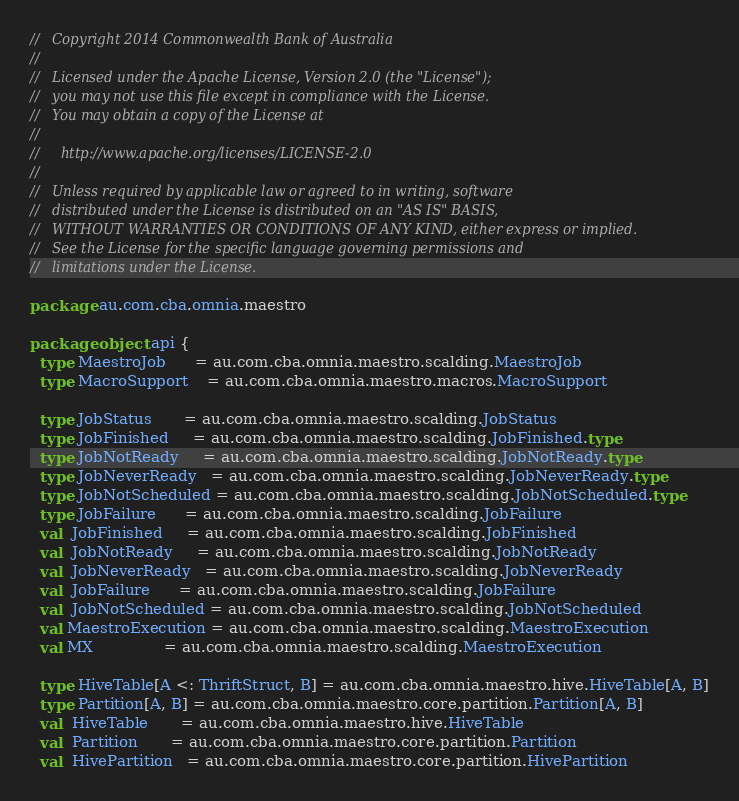<code> <loc_0><loc_0><loc_500><loc_500><_Scala_>//   Copyright 2014 Commonwealth Bank of Australia
//
//   Licensed under the Apache License, Version 2.0 (the "License");
//   you may not use this file except in compliance with the License.
//   You may obtain a copy of the License at
//
//     http://www.apache.org/licenses/LICENSE-2.0
//
//   Unless required by applicable law or agreed to in writing, software
//   distributed under the License is distributed on an "AS IS" BASIS,
//   WITHOUT WARRANTIES OR CONDITIONS OF ANY KIND, either express or implied.
//   See the License for the specific language governing permissions and
//   limitations under the License.

package au.com.cba.omnia.maestro

package object api {
  type MaestroJob      = au.com.cba.omnia.maestro.scalding.MaestroJob
  type MacroSupport    = au.com.cba.omnia.maestro.macros.MacroSupport

  type JobStatus       = au.com.cba.omnia.maestro.scalding.JobStatus
  type JobFinished     = au.com.cba.omnia.maestro.scalding.JobFinished.type
  type JobNotReady     = au.com.cba.omnia.maestro.scalding.JobNotReady.type
  type JobNeverReady   = au.com.cba.omnia.maestro.scalding.JobNeverReady.type
  type JobNotScheduled = au.com.cba.omnia.maestro.scalding.JobNotScheduled.type
  type JobFailure      = au.com.cba.omnia.maestro.scalding.JobFailure
  val  JobFinished     = au.com.cba.omnia.maestro.scalding.JobFinished
  val  JobNotReady     = au.com.cba.omnia.maestro.scalding.JobNotReady
  val  JobNeverReady   = au.com.cba.omnia.maestro.scalding.JobNeverReady
  val  JobFailure      = au.com.cba.omnia.maestro.scalding.JobFailure
  val  JobNotScheduled = au.com.cba.omnia.maestro.scalding.JobNotScheduled
  val MaestroExecution = au.com.cba.omnia.maestro.scalding.MaestroExecution
  val MX               = au.com.cba.omnia.maestro.scalding.MaestroExecution

  type HiveTable[A <: ThriftStruct, B] = au.com.cba.omnia.maestro.hive.HiveTable[A, B]
  type Partition[A, B] = au.com.cba.omnia.maestro.core.partition.Partition[A, B]
  val  HiveTable       = au.com.cba.omnia.maestro.hive.HiveTable
  val  Partition       = au.com.cba.omnia.maestro.core.partition.Partition
  val  HivePartition   = au.com.cba.omnia.maestro.core.partition.HivePartition
</code> 